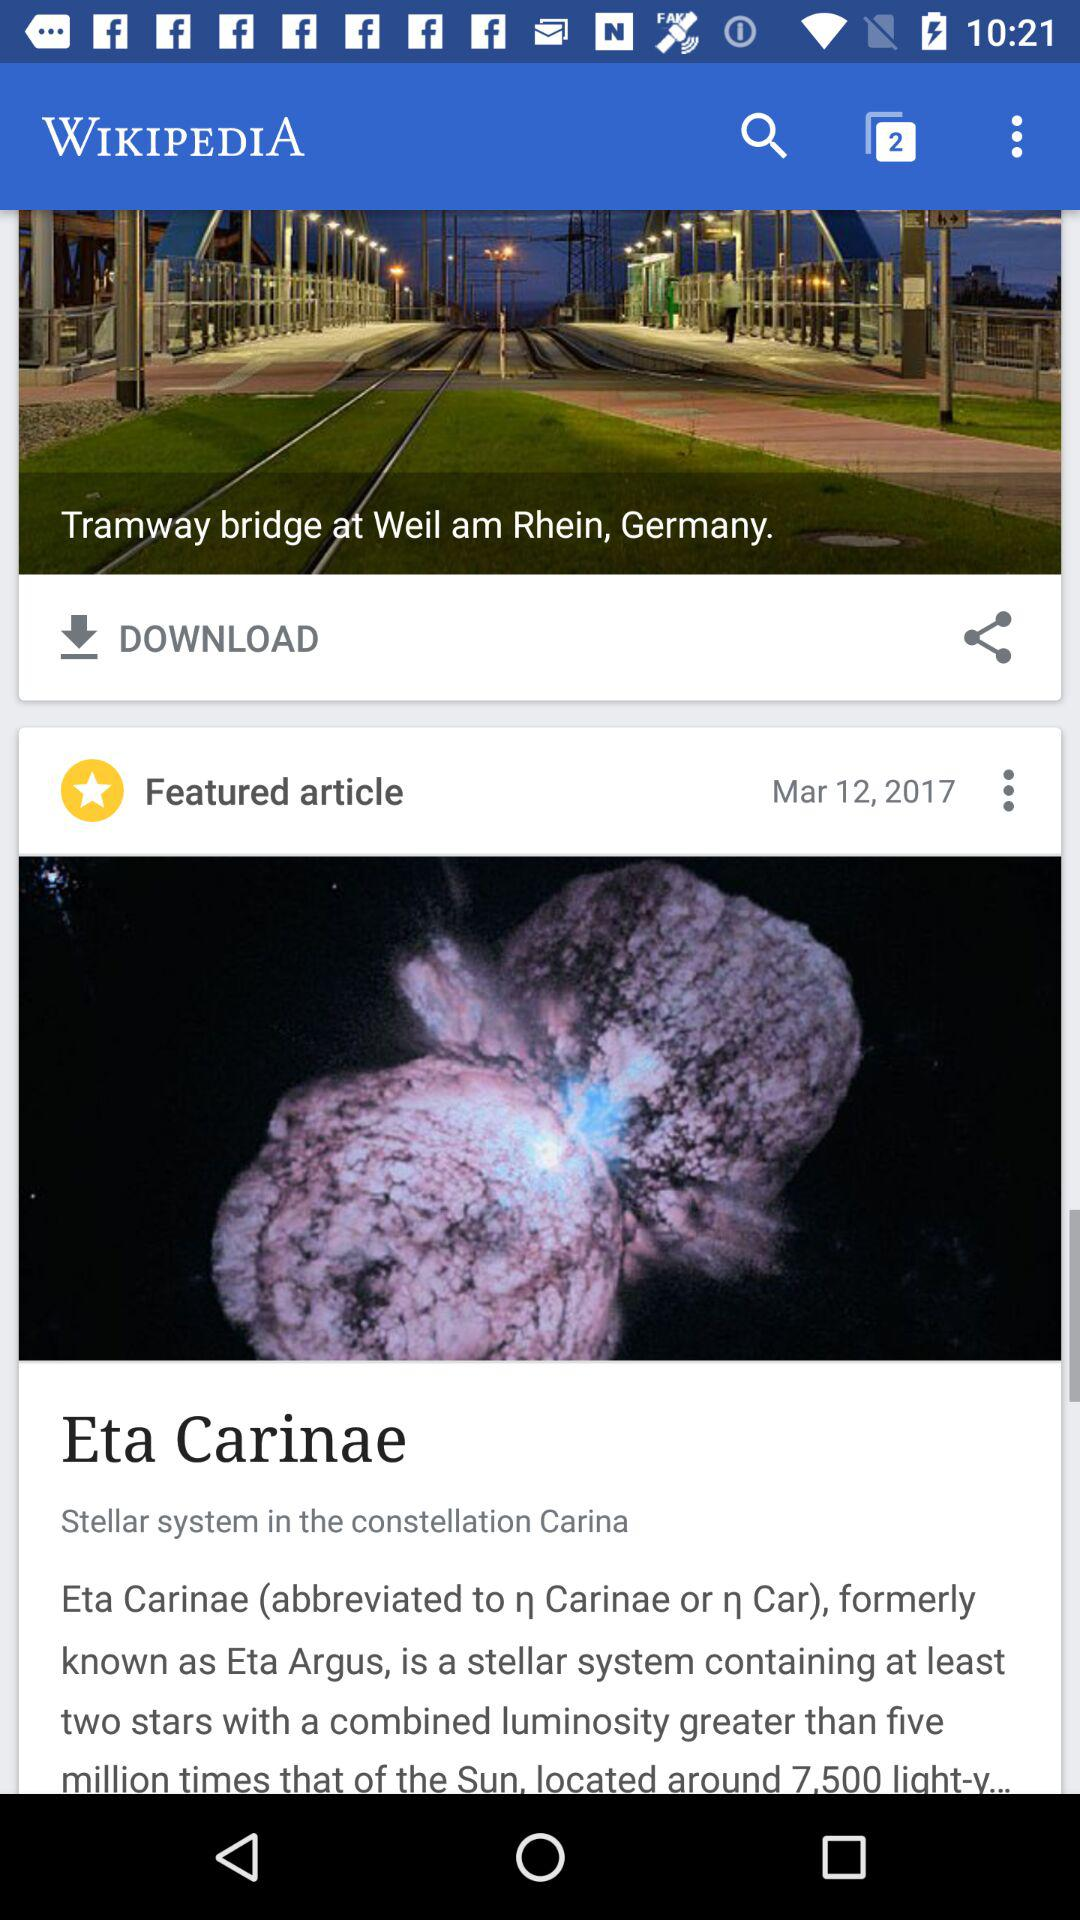On what date was the article posted? The article was posted on March 12, 2017. 